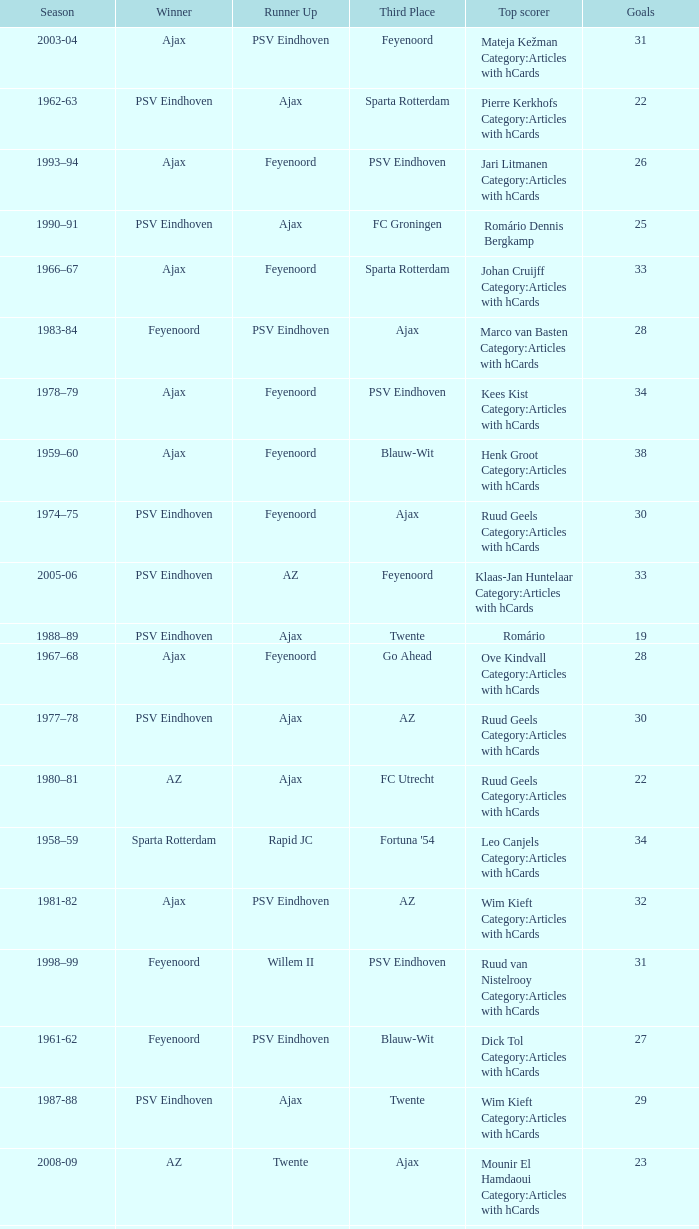When az is the runner up nad feyenoord came in third place how many overall winners are there? 1.0. 